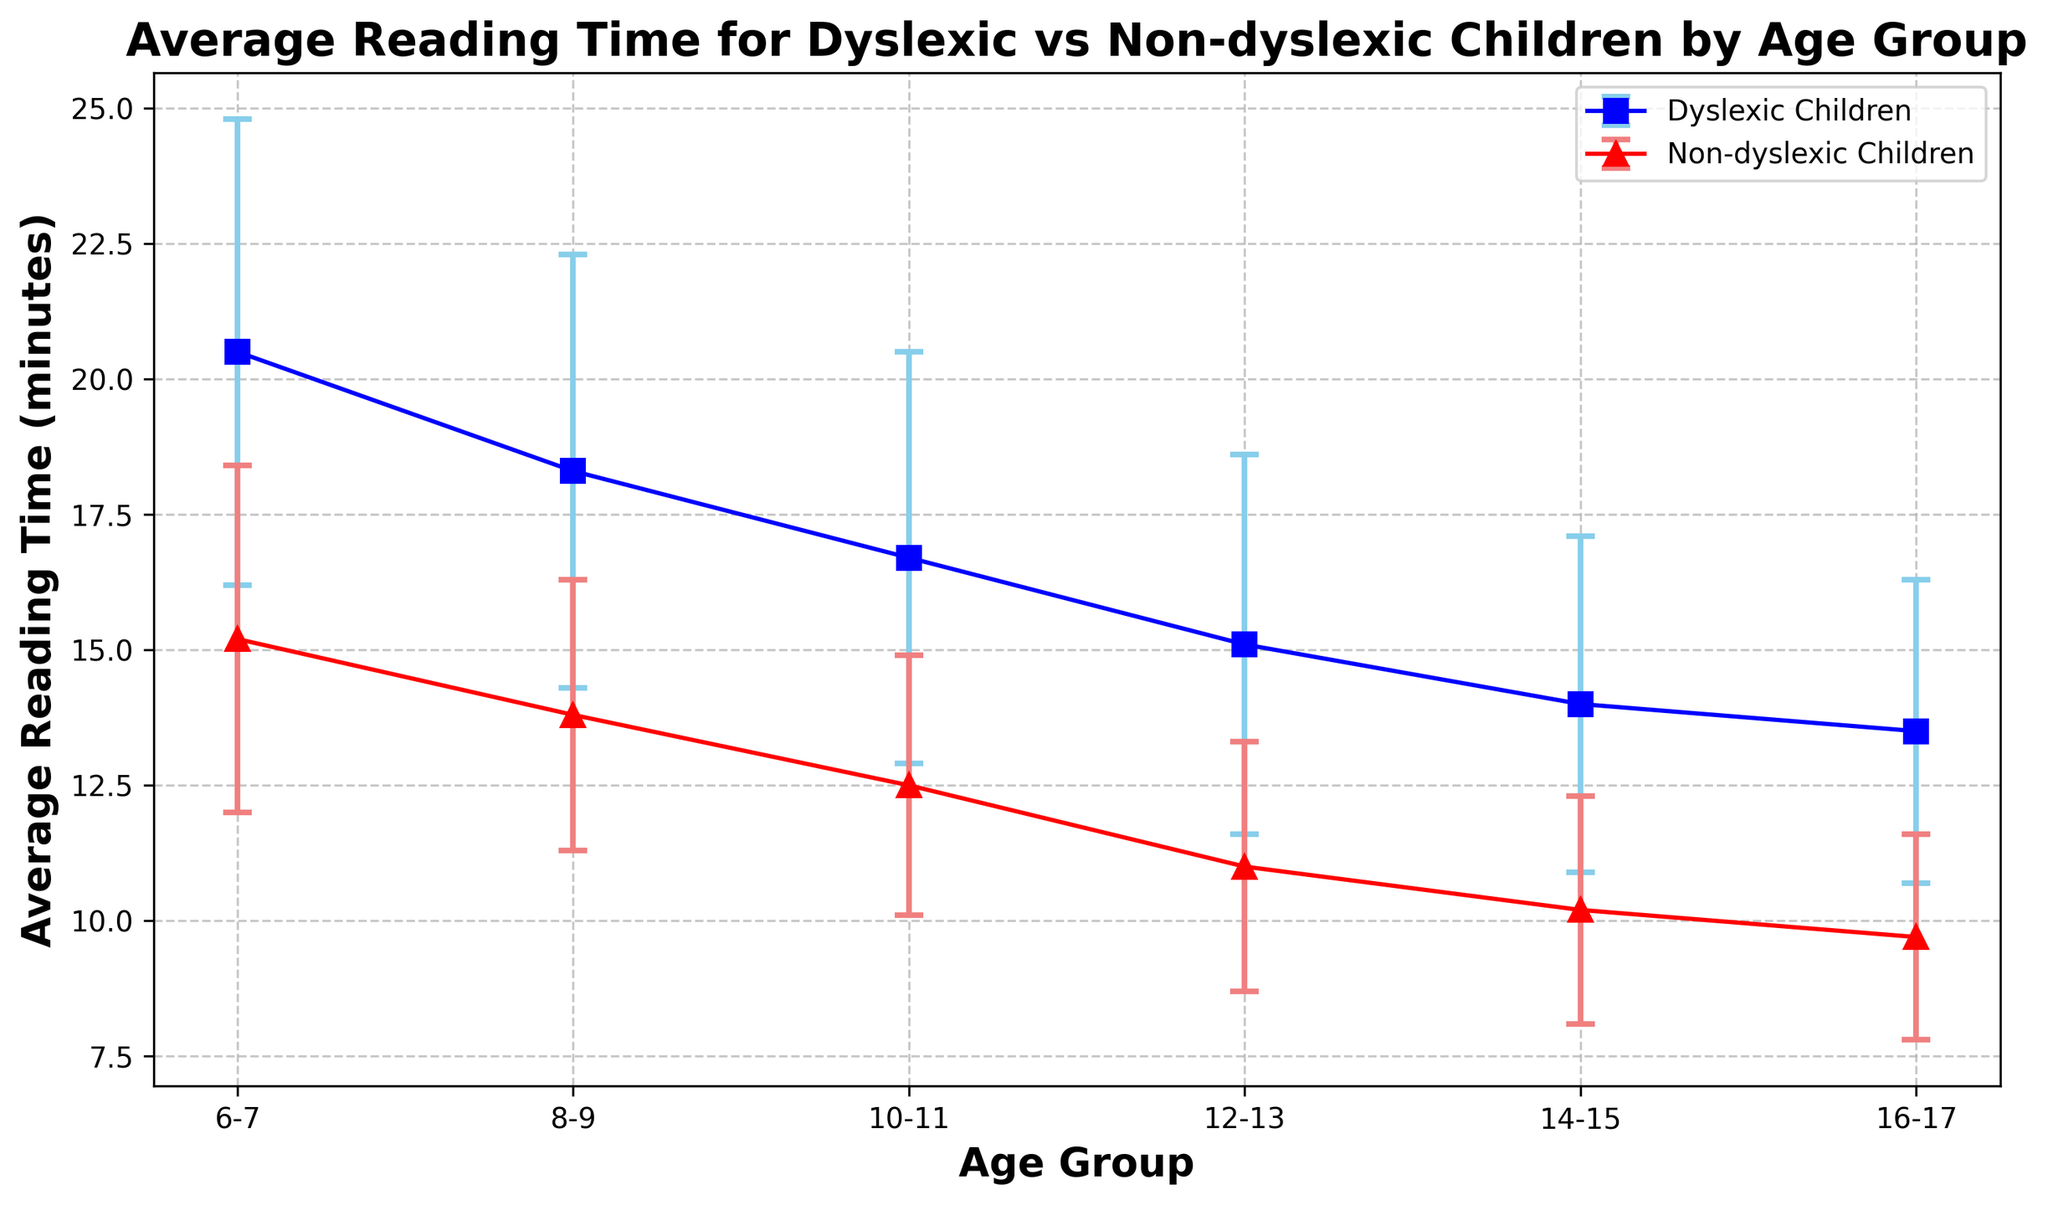What's the average reading time for dyslexic children in the 12-13 and 14-15 age groups combined? To find the combined average reading time, sum the average reading times for the 12-13 and 14-15 age groups and then divide by 2. For dyslexic children, the values are 15.1 and 14.0. (15.1 + 14.0) / 2 = 14.55
Answer: 14.55 In which age group is the difference in average reading time between dyslexic and non-dyslexic children the greatest? Calculate the difference in average reading times for each age group and compare. The differences are: 6-7: 20.5 - 15.2 = 5.3, 8-9: 18.3 - 13.8 = 4.5, 10-11: 16.7 - 12.5 = 4.2, 12-13: 15.1 - 11.0 = 4.1, 14-15: 14.0 - 10.2 = 3.8, 16-17: 13.5 - 9.7 = 3.8. The greatest difference is 5.3 in the 6-7 age group.
Answer: 6-7 What is the range of the average reading times for non-dyslexic children? The range is the difference between the maximum and minimum average reading times for non-dyslexic children. The maximum is 15.2 (age 6-7) and the minimum is 9.7 (age 16-17). 15.2 - 9.7 = 5.5
Answer: 5.5 Which group has a steeper decline in average reading time as age increases, dyslexic or non-dyslexic children? To determine steepness, compare the overall change in average reading times from the youngest to the oldest age group for both dyslexic and non-dyslexic children. Dyslexic group: 20.5 to 13.5, a change of 7.0; Non-dyslexic group: 15.2 to 9.7, a change of 5.5. Dyslexic children have a steeper decline.
Answer: Dyslexic children In the 10-11 age group, how much higher is the average reading time for dyslexic children compared to non-dyslexic children? Subtract the average reading time of non-dyslexic children from that of dyslexic children in the 10-11 age group. 16.7 - 12.5 = 4.2
Answer: 4.2 What is the average reading time for non-dyslexic children in the 8-9 and 10-11 age groups combined? Sum the average reading times for the 8-9 and 10-11 age groups and divide by 2. For non-dyslexic children, the values are 13.8 and 12.5. (13.8 + 12.5) / 2 = 13.15
Answer: 13.15 What does the height and position of the error bars indicate about the variability in reading times? Higher and longer error bars indicate greater variability in the reading times, while shorter error bars indicate less variability. The error bars for dyslexic children are generally higher, indicating more variability compared to non-dyslexic children.
Answer: Greater variability for dyslexic children Between which two consecutive age groups is the drop in average reading time most significant for dyslexic children? Calculate the drop between consecutive age groups for dyslexic children: 6-7 to 8-9: 20.5 - 18.3 = 2.2, 8-9 to 10-11: 18.3 - 16.7 = 1.6, 10-11 to 12-13: 16.7 - 15.1 = 1.6, 12-13 to 14-15: 15.1 - 14.0 = 1.1, 14-15 to 16-17: 14.0 - 13.5 = 0.5. The most significant drop is 2.2 between 6-7 and 8-9.
Answer: 6-7 to 8-9 